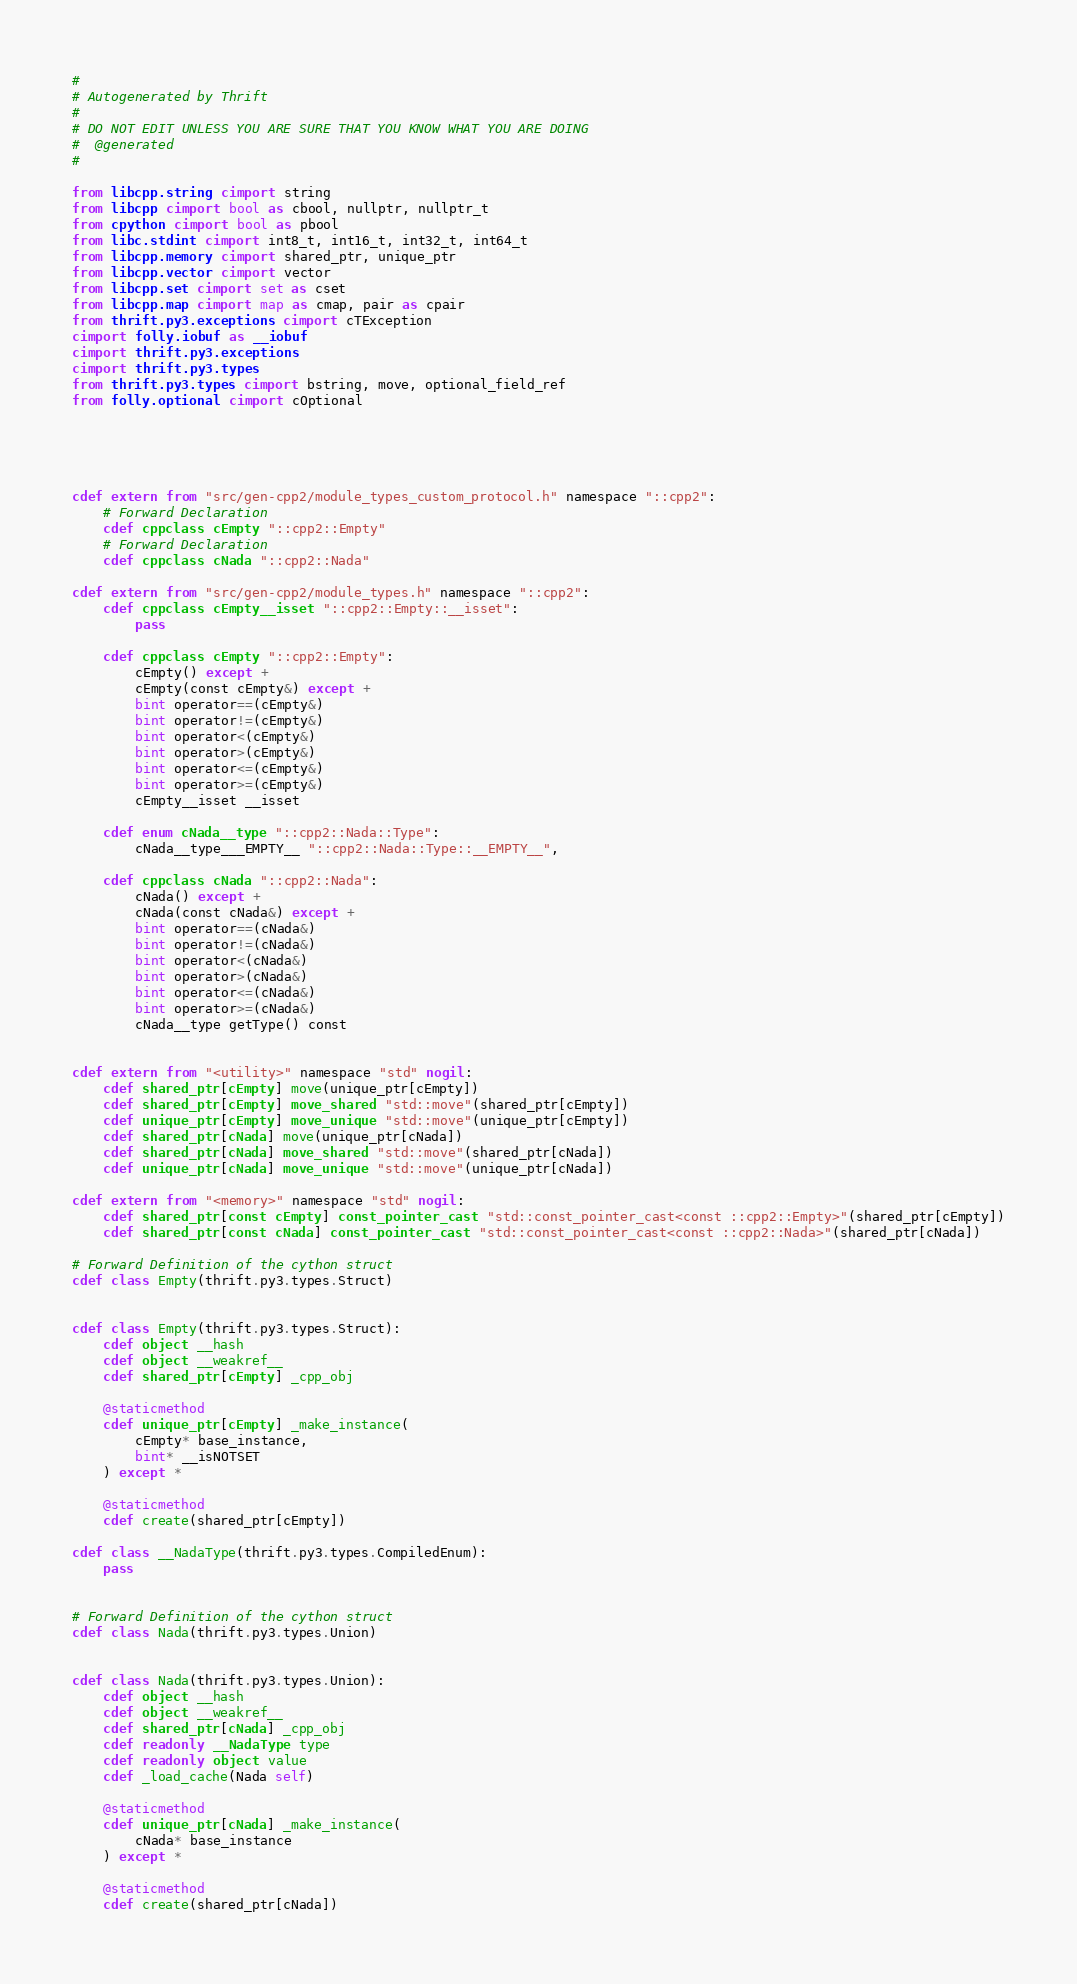<code> <loc_0><loc_0><loc_500><loc_500><_Cython_>#
# Autogenerated by Thrift
#
# DO NOT EDIT UNLESS YOU ARE SURE THAT YOU KNOW WHAT YOU ARE DOING
#  @generated
#

from libcpp.string cimport string
from libcpp cimport bool as cbool, nullptr, nullptr_t
from cpython cimport bool as pbool
from libc.stdint cimport int8_t, int16_t, int32_t, int64_t
from libcpp.memory cimport shared_ptr, unique_ptr
from libcpp.vector cimport vector
from libcpp.set cimport set as cset
from libcpp.map cimport map as cmap, pair as cpair
from thrift.py3.exceptions cimport cTException
cimport folly.iobuf as __iobuf
cimport thrift.py3.exceptions
cimport thrift.py3.types
from thrift.py3.types cimport bstring, move, optional_field_ref
from folly.optional cimport cOptional





cdef extern from "src/gen-cpp2/module_types_custom_protocol.h" namespace "::cpp2":
    # Forward Declaration
    cdef cppclass cEmpty "::cpp2::Empty"
    # Forward Declaration
    cdef cppclass cNada "::cpp2::Nada"

cdef extern from "src/gen-cpp2/module_types.h" namespace "::cpp2":
    cdef cppclass cEmpty__isset "::cpp2::Empty::__isset":
        pass

    cdef cppclass cEmpty "::cpp2::Empty":
        cEmpty() except +
        cEmpty(const cEmpty&) except +
        bint operator==(cEmpty&)
        bint operator!=(cEmpty&)
        bint operator<(cEmpty&)
        bint operator>(cEmpty&)
        bint operator<=(cEmpty&)
        bint operator>=(cEmpty&)
        cEmpty__isset __isset

    cdef enum cNada__type "::cpp2::Nada::Type":
        cNada__type___EMPTY__ "::cpp2::Nada::Type::__EMPTY__",

    cdef cppclass cNada "::cpp2::Nada":
        cNada() except +
        cNada(const cNada&) except +
        bint operator==(cNada&)
        bint operator!=(cNada&)
        bint operator<(cNada&)
        bint operator>(cNada&)
        bint operator<=(cNada&)
        bint operator>=(cNada&)
        cNada__type getType() const


cdef extern from "<utility>" namespace "std" nogil:
    cdef shared_ptr[cEmpty] move(unique_ptr[cEmpty])
    cdef shared_ptr[cEmpty] move_shared "std::move"(shared_ptr[cEmpty])
    cdef unique_ptr[cEmpty] move_unique "std::move"(unique_ptr[cEmpty])
    cdef shared_ptr[cNada] move(unique_ptr[cNada])
    cdef shared_ptr[cNada] move_shared "std::move"(shared_ptr[cNada])
    cdef unique_ptr[cNada] move_unique "std::move"(unique_ptr[cNada])

cdef extern from "<memory>" namespace "std" nogil:
    cdef shared_ptr[const cEmpty] const_pointer_cast "std::const_pointer_cast<const ::cpp2::Empty>"(shared_ptr[cEmpty])
    cdef shared_ptr[const cNada] const_pointer_cast "std::const_pointer_cast<const ::cpp2::Nada>"(shared_ptr[cNada])

# Forward Definition of the cython struct
cdef class Empty(thrift.py3.types.Struct)


cdef class Empty(thrift.py3.types.Struct):
    cdef object __hash
    cdef object __weakref__
    cdef shared_ptr[cEmpty] _cpp_obj

    @staticmethod
    cdef unique_ptr[cEmpty] _make_instance(
        cEmpty* base_instance,
        bint* __isNOTSET
    ) except *

    @staticmethod
    cdef create(shared_ptr[cEmpty])

cdef class __NadaType(thrift.py3.types.CompiledEnum):
    pass


# Forward Definition of the cython struct
cdef class Nada(thrift.py3.types.Union)


cdef class Nada(thrift.py3.types.Union):
    cdef object __hash
    cdef object __weakref__
    cdef shared_ptr[cNada] _cpp_obj
    cdef readonly __NadaType type
    cdef readonly object value
    cdef _load_cache(Nada self)

    @staticmethod
    cdef unique_ptr[cNada] _make_instance(
        cNada* base_instance
    ) except *

    @staticmethod
    cdef create(shared_ptr[cNada])





</code> 